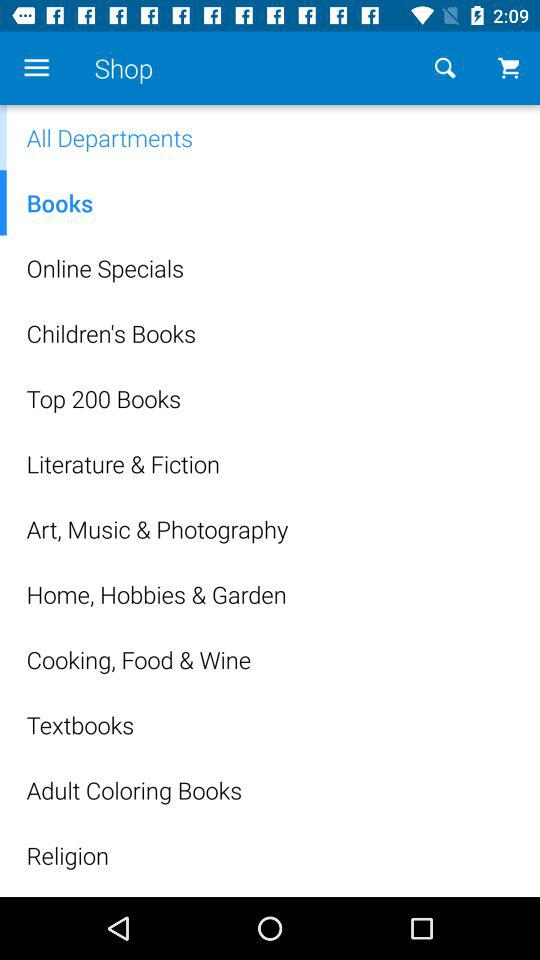What are the categories of books? The categories are "Online Specials", "Children's Books", "Top 200 Books", "Literature & Fiction", "Art, Music & Photography", "Home, Hobbies & Garden", "Cooking, Food & Wine", "Textbooks", "Adult Coloring Books" and "Religion". 